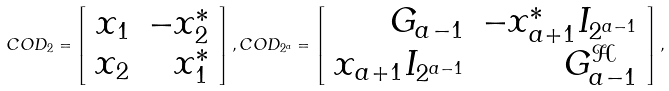<formula> <loc_0><loc_0><loc_500><loc_500>C O D _ { 2 } = \left [ \begin{array} { r r } x _ { 1 } & - x _ { 2 } ^ { * } \\ x _ { 2 } & x _ { 1 } ^ { * } \end{array} \right ] , C O D _ { 2 ^ { a } } = \left [ \begin{array} { r r } { G } _ { a - 1 } & - x _ { a + 1 } ^ { * } { I } _ { 2 ^ { a - 1 } } \\ x _ { a + 1 } { I } _ { 2 ^ { a - 1 } } & { G } _ { a - 1 } ^ { \mathcal { H } } \end{array} \right ] ,</formula> 